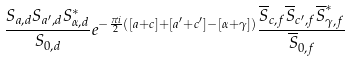Convert formula to latex. <formula><loc_0><loc_0><loc_500><loc_500>\frac { S _ { a , d } S _ { a ^ { \prime } , d } S _ { \alpha , d } ^ { * } } { S _ { 0 , d } } e ^ { - \frac { \pi i } { 2 } ( [ a + c ] + [ a ^ { \prime } + c ^ { \prime } ] - [ \alpha + \gamma ] ) } \frac { \overline { S } _ { c , f } \overline { S } _ { c ^ { \prime } , f } \overline { S } _ { \gamma , f } ^ { * } } { \overline { S } _ { 0 , f } }</formula> 